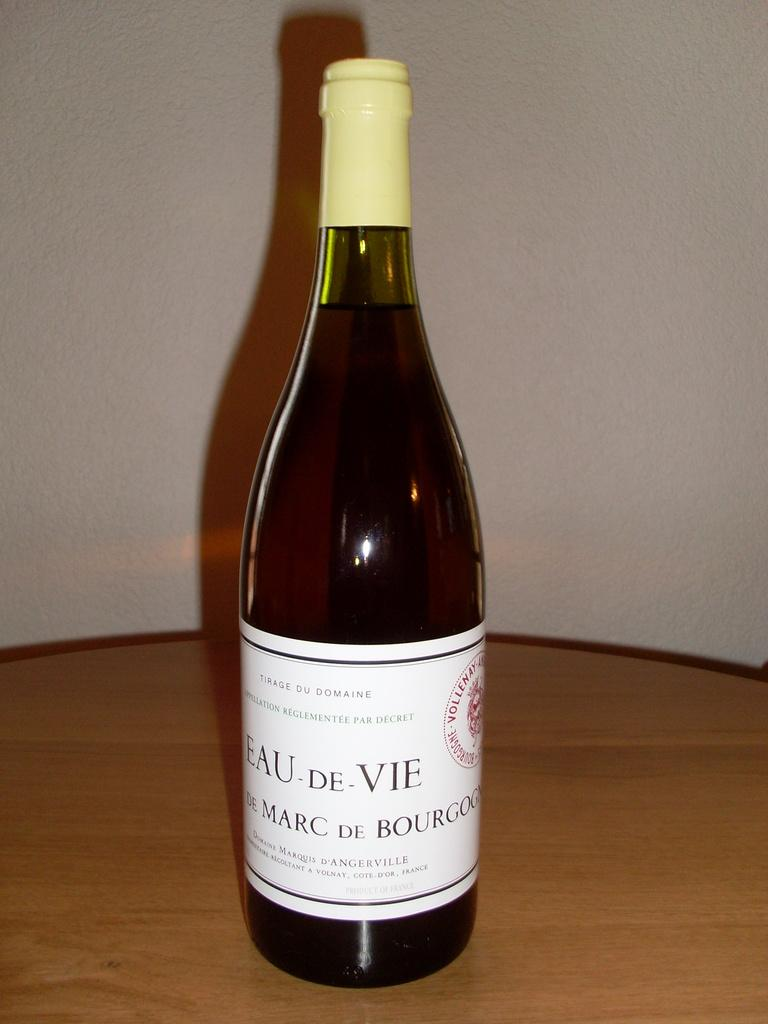<image>
Summarize the visual content of the image. A bottle says "EAU DE VIE" on the white label. 